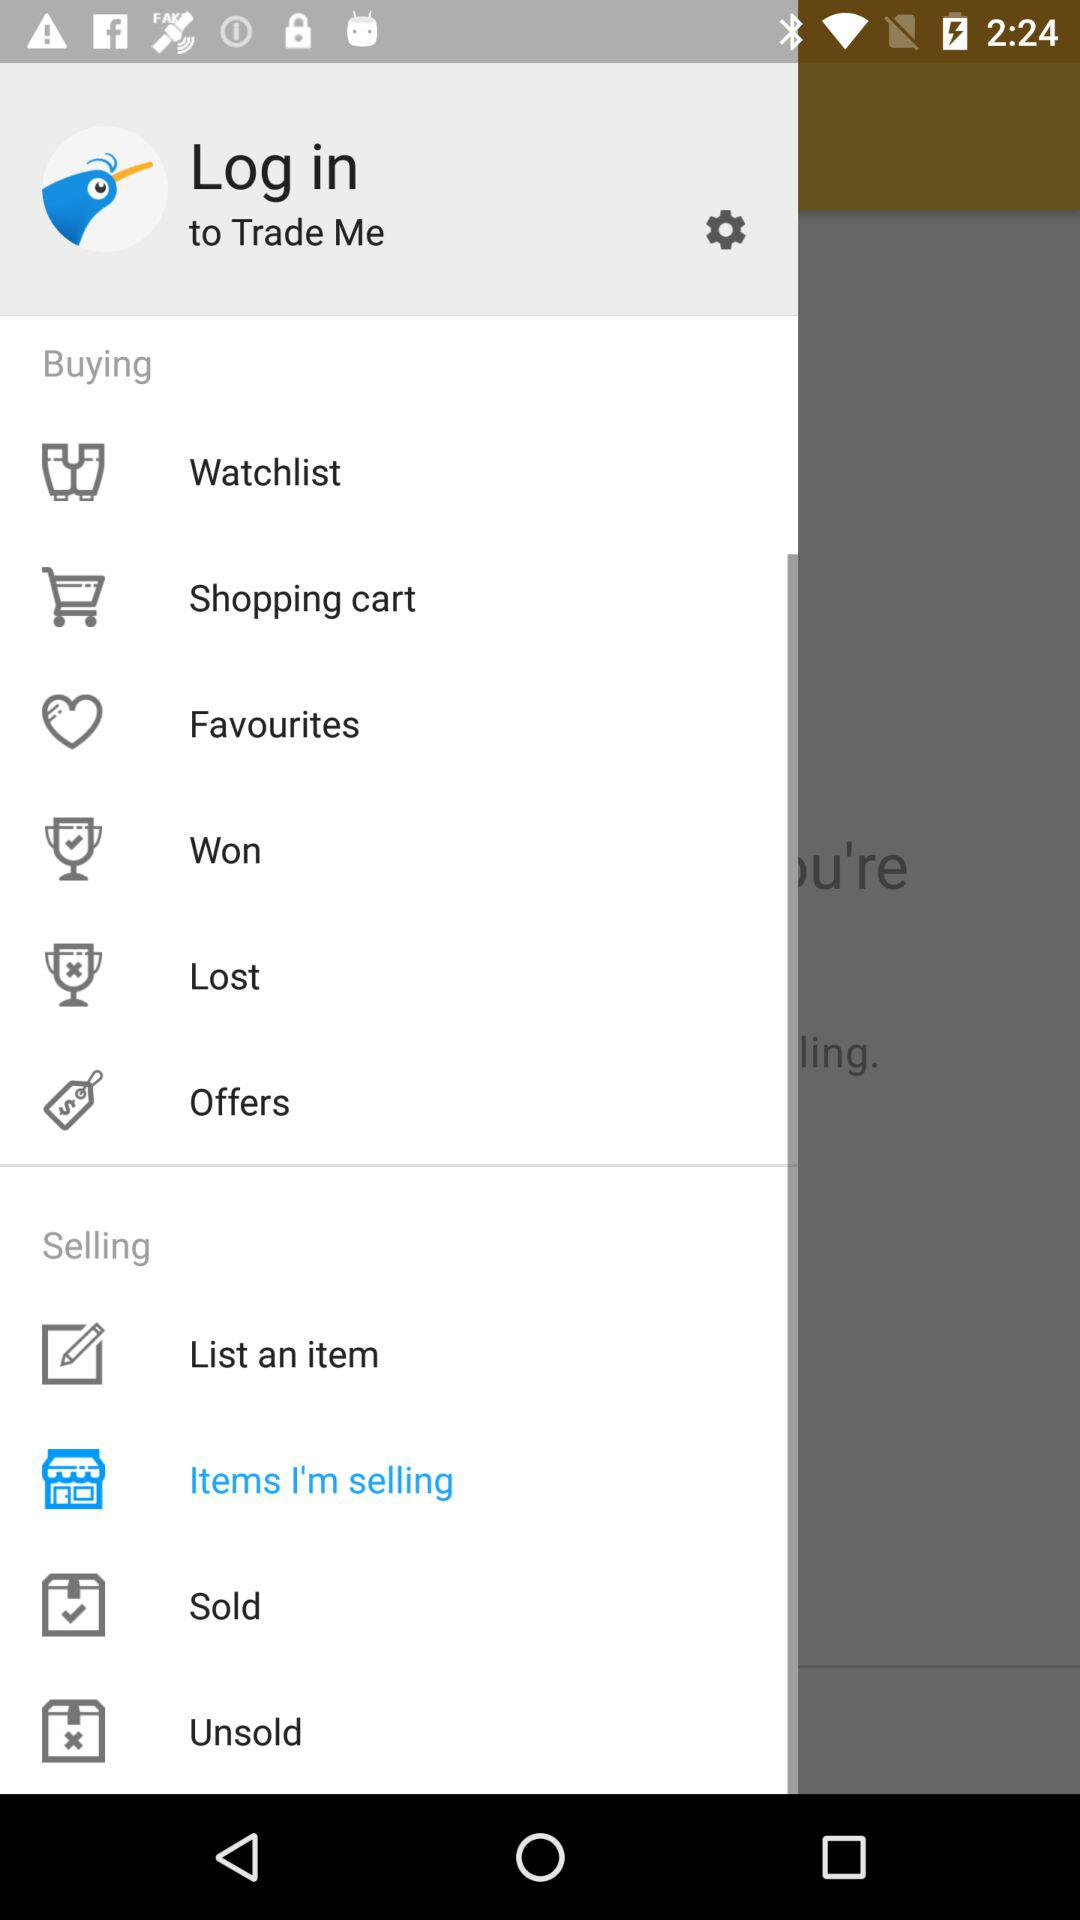What is the app name? The app name is "Trade Me". 